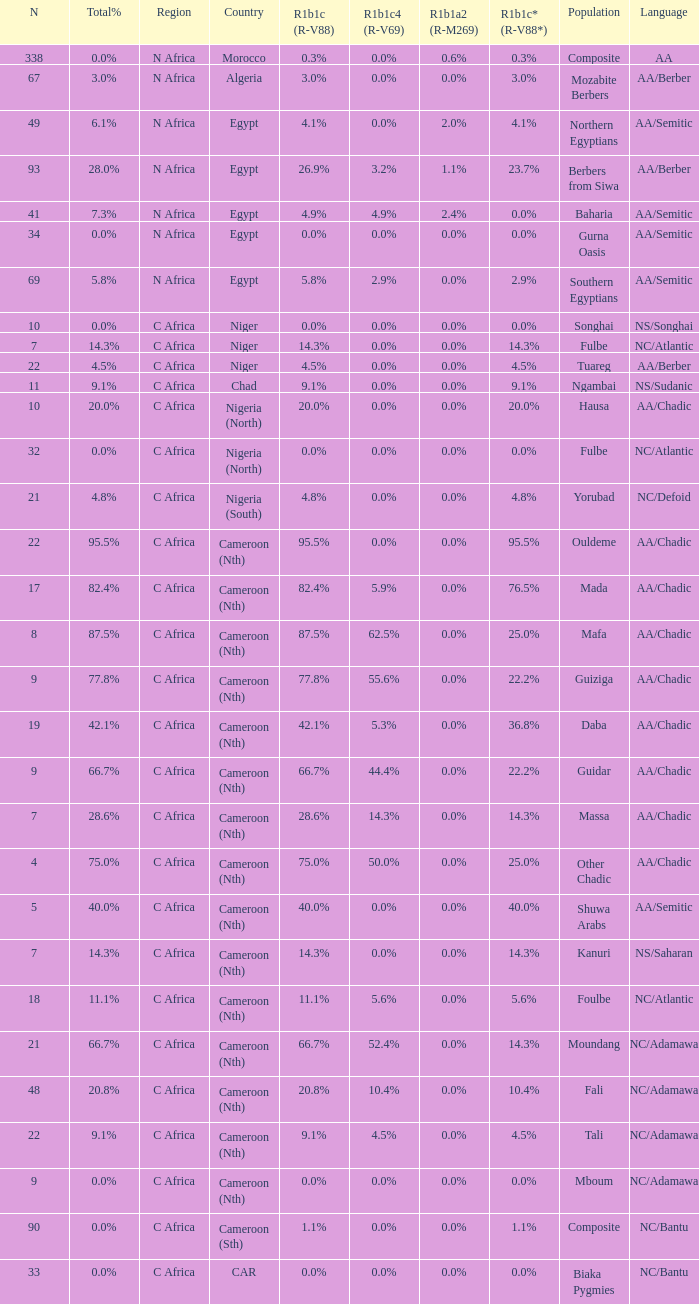How many n are listed for berbers from siwa? 1.0. Parse the full table. {'header': ['N', 'Total%', 'Region', 'Country', 'R1b1c (R-V88)', 'R1b1c4 (R-V69)', 'R1b1a2 (R-M269)', 'R1b1c* (R-V88*)', 'Population', 'Language'], 'rows': [['338', '0.0%', 'N Africa', 'Morocco', '0.3%', '0.0%', '0.6%', '0.3%', 'Composite', 'AA'], ['67', '3.0%', 'N Africa', 'Algeria', '3.0%', '0.0%', '0.0%', '3.0%', 'Mozabite Berbers', 'AA/Berber'], ['49', '6.1%', 'N Africa', 'Egypt', '4.1%', '0.0%', '2.0%', '4.1%', 'Northern Egyptians', 'AA/Semitic'], ['93', '28.0%', 'N Africa', 'Egypt', '26.9%', '3.2%', '1.1%', '23.7%', 'Berbers from Siwa', 'AA/Berber'], ['41', '7.3%', 'N Africa', 'Egypt', '4.9%', '4.9%', '2.4%', '0.0%', 'Baharia', 'AA/Semitic'], ['34', '0.0%', 'N Africa', 'Egypt', '0.0%', '0.0%', '0.0%', '0.0%', 'Gurna Oasis', 'AA/Semitic'], ['69', '5.8%', 'N Africa', 'Egypt', '5.8%', '2.9%', '0.0%', '2.9%', 'Southern Egyptians', 'AA/Semitic'], ['10', '0.0%', 'C Africa', 'Niger', '0.0%', '0.0%', '0.0%', '0.0%', 'Songhai', 'NS/Songhai'], ['7', '14.3%', 'C Africa', 'Niger', '14.3%', '0.0%', '0.0%', '14.3%', 'Fulbe', 'NC/Atlantic'], ['22', '4.5%', 'C Africa', 'Niger', '4.5%', '0.0%', '0.0%', '4.5%', 'Tuareg', 'AA/Berber'], ['11', '9.1%', 'C Africa', 'Chad', '9.1%', '0.0%', '0.0%', '9.1%', 'Ngambai', 'NS/Sudanic'], ['10', '20.0%', 'C Africa', 'Nigeria (North)', '20.0%', '0.0%', '0.0%', '20.0%', 'Hausa', 'AA/Chadic'], ['32', '0.0%', 'C Africa', 'Nigeria (North)', '0.0%', '0.0%', '0.0%', '0.0%', 'Fulbe', 'NC/Atlantic'], ['21', '4.8%', 'C Africa', 'Nigeria (South)', '4.8%', '0.0%', '0.0%', '4.8%', 'Yorubad', 'NC/Defoid'], ['22', '95.5%', 'C Africa', 'Cameroon (Nth)', '95.5%', '0.0%', '0.0%', '95.5%', 'Ouldeme', 'AA/Chadic'], ['17', '82.4%', 'C Africa', 'Cameroon (Nth)', '82.4%', '5.9%', '0.0%', '76.5%', 'Mada', 'AA/Chadic'], ['8', '87.5%', 'C Africa', 'Cameroon (Nth)', '87.5%', '62.5%', '0.0%', '25.0%', 'Mafa', 'AA/Chadic'], ['9', '77.8%', 'C Africa', 'Cameroon (Nth)', '77.8%', '55.6%', '0.0%', '22.2%', 'Guiziga', 'AA/Chadic'], ['19', '42.1%', 'C Africa', 'Cameroon (Nth)', '42.1%', '5.3%', '0.0%', '36.8%', 'Daba', 'AA/Chadic'], ['9', '66.7%', 'C Africa', 'Cameroon (Nth)', '66.7%', '44.4%', '0.0%', '22.2%', 'Guidar', 'AA/Chadic'], ['7', '28.6%', 'C Africa', 'Cameroon (Nth)', '28.6%', '14.3%', '0.0%', '14.3%', 'Massa', 'AA/Chadic'], ['4', '75.0%', 'C Africa', 'Cameroon (Nth)', '75.0%', '50.0%', '0.0%', '25.0%', 'Other Chadic', 'AA/Chadic'], ['5', '40.0%', 'C Africa', 'Cameroon (Nth)', '40.0%', '0.0%', '0.0%', '40.0%', 'Shuwa Arabs', 'AA/Semitic'], ['7', '14.3%', 'C Africa', 'Cameroon (Nth)', '14.3%', '0.0%', '0.0%', '14.3%', 'Kanuri', 'NS/Saharan'], ['18', '11.1%', 'C Africa', 'Cameroon (Nth)', '11.1%', '5.6%', '0.0%', '5.6%', 'Foulbe', 'NC/Atlantic'], ['21', '66.7%', 'C Africa', 'Cameroon (Nth)', '66.7%', '52.4%', '0.0%', '14.3%', 'Moundang', 'NC/Adamawa'], ['48', '20.8%', 'C Africa', 'Cameroon (Nth)', '20.8%', '10.4%', '0.0%', '10.4%', 'Fali', 'NC/Adamawa'], ['22', '9.1%', 'C Africa', 'Cameroon (Nth)', '9.1%', '4.5%', '0.0%', '4.5%', 'Tali', 'NC/Adamawa'], ['9', '0.0%', 'C Africa', 'Cameroon (Nth)', '0.0%', '0.0%', '0.0%', '0.0%', 'Mboum', 'NC/Adamawa'], ['90', '0.0%', 'C Africa', 'Cameroon (Sth)', '1.1%', '0.0%', '0.0%', '1.1%', 'Composite', 'NC/Bantu'], ['33', '0.0%', 'C Africa', 'CAR', '0.0%', '0.0%', '0.0%', '0.0%', 'Biaka Pygmies', 'NC/Bantu']]} 